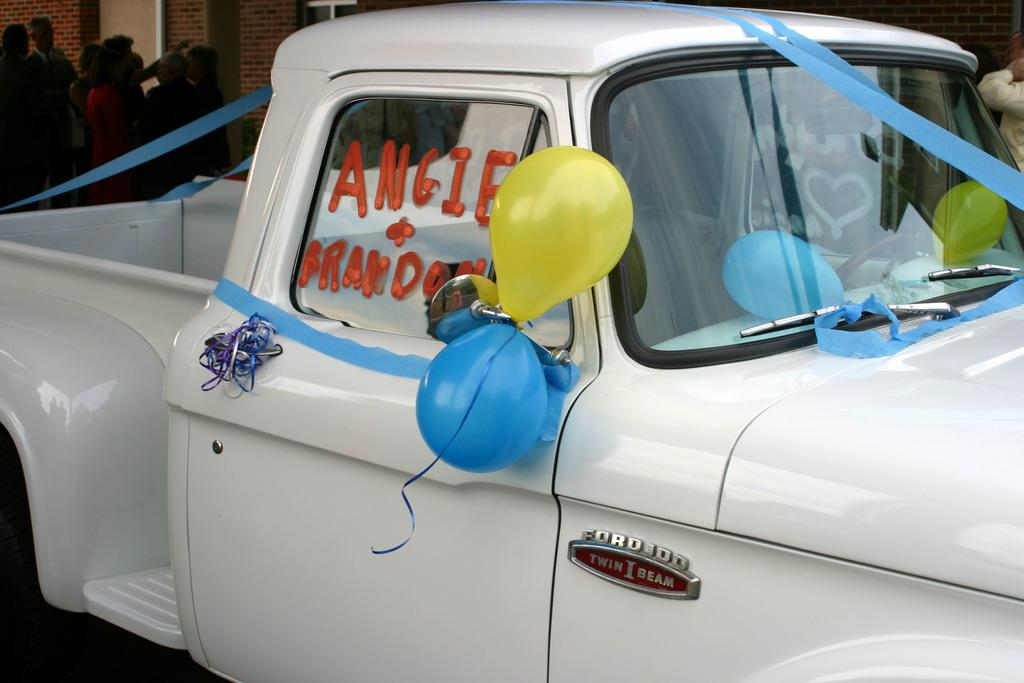What is the main subject of the image? There is a vehicle in the image. What distinguishes this vehicle from others? The vehicle has balloons and ribbons attached to it. Can you describe the background of the image? There are people standing in the background of the image, and there is a wall present. What type of weather can be seen in the image? The provided facts do not mention any weather conditions, so it cannot be determined from the image. 